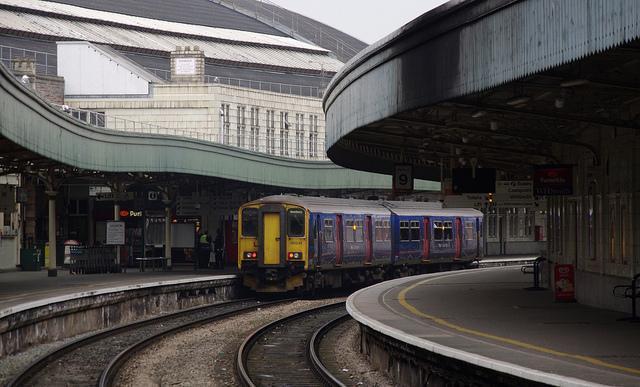How many trains are there?
Give a very brief answer. 1. 